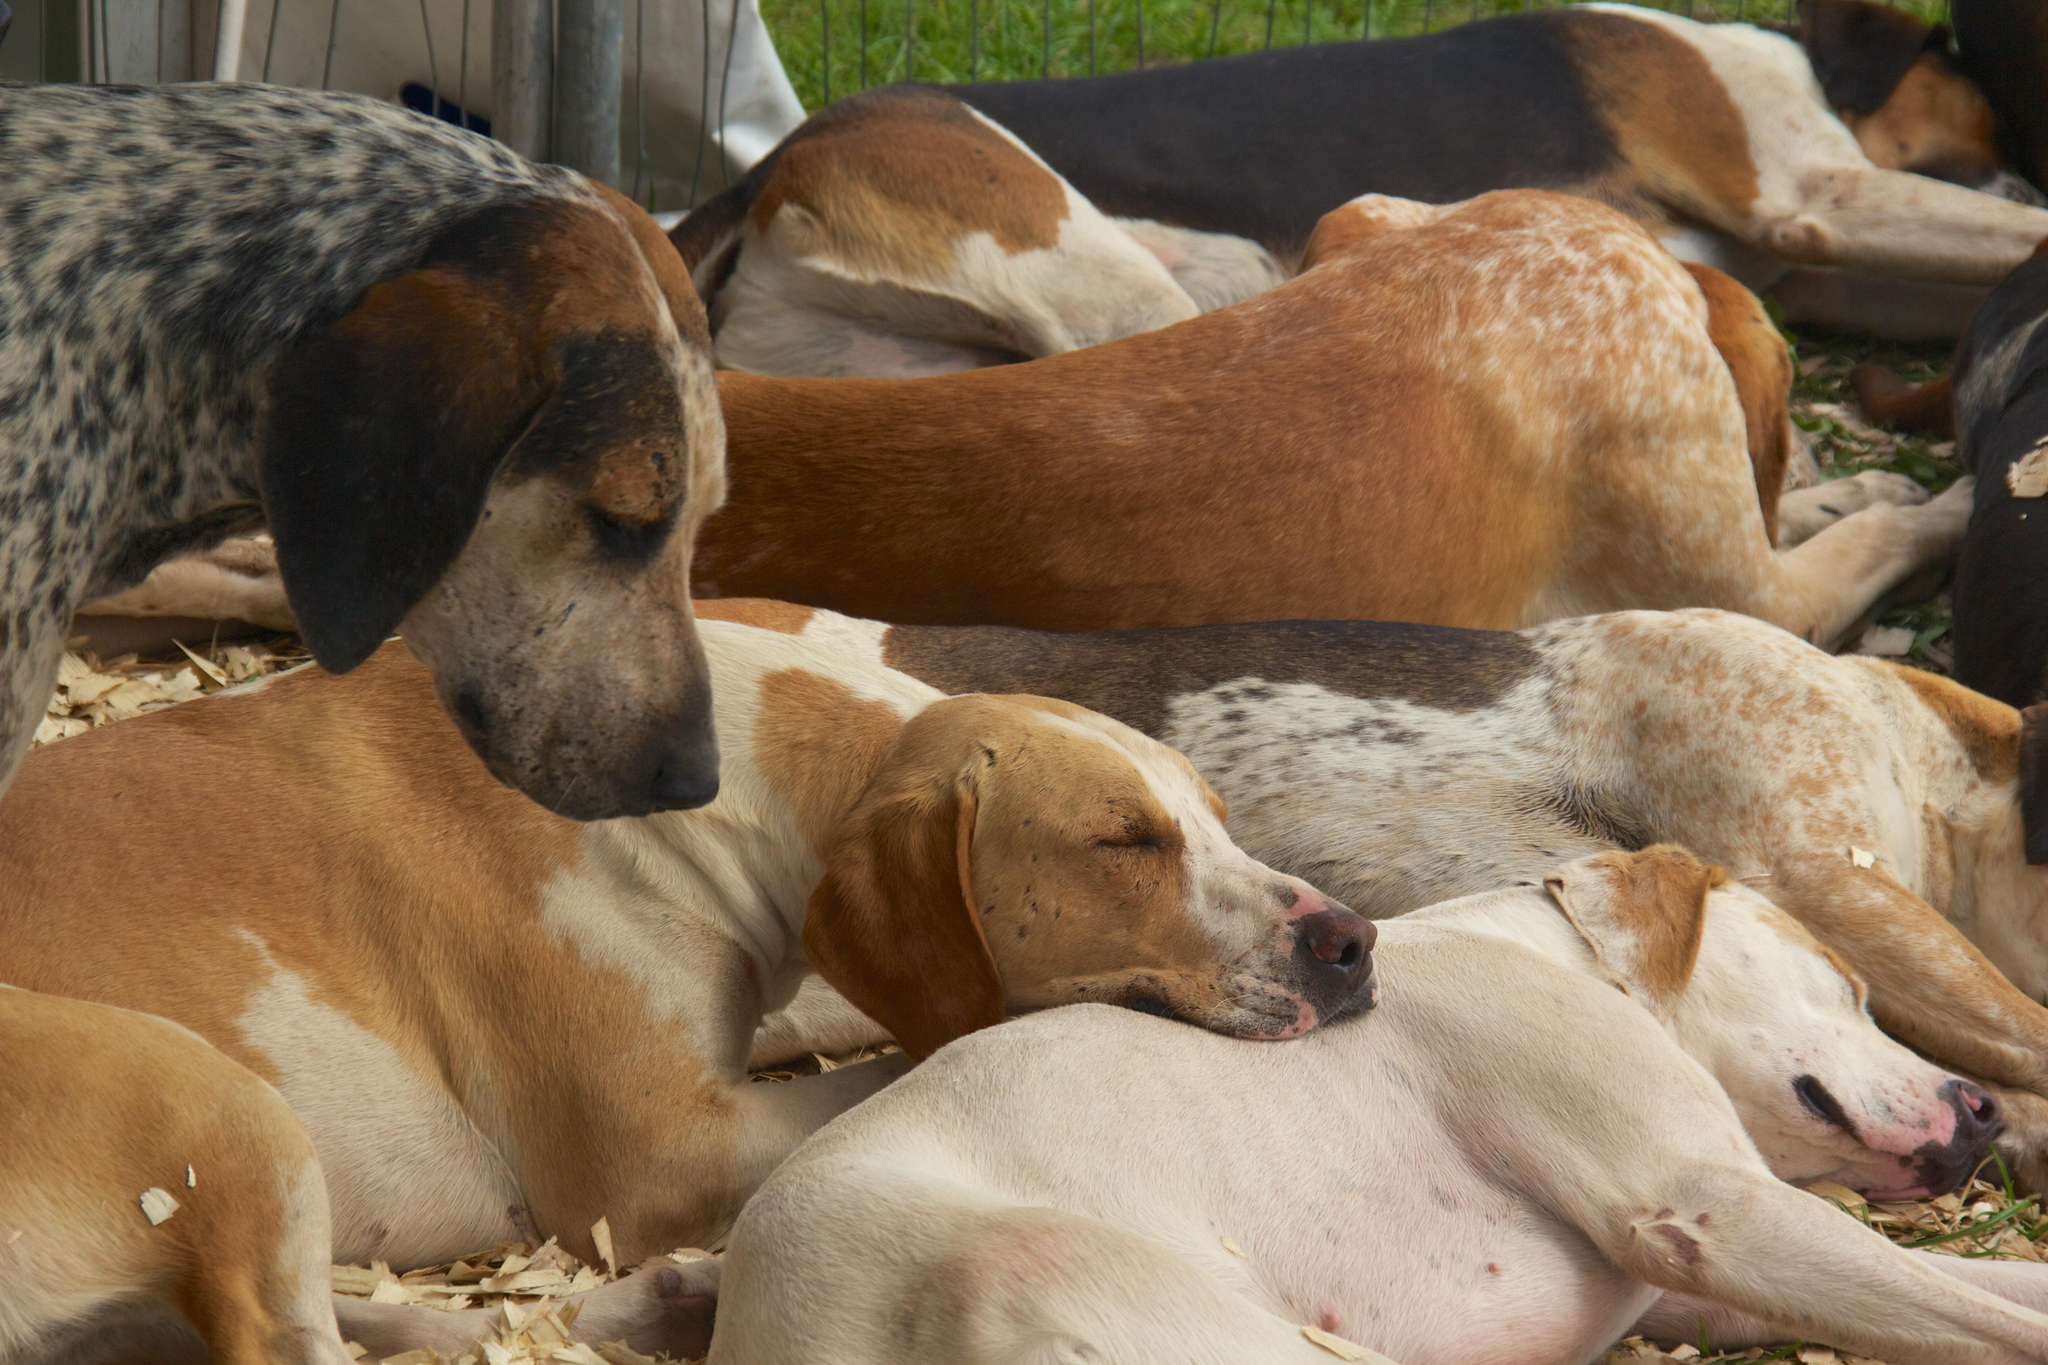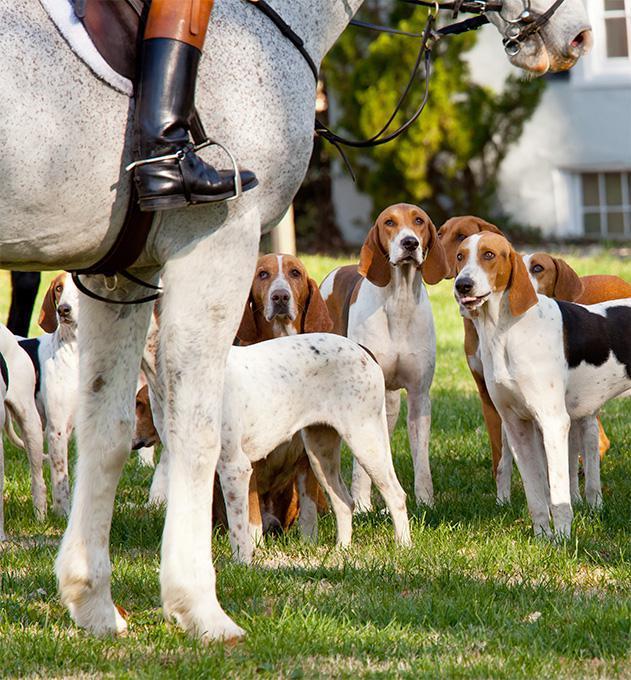The first image is the image on the left, the second image is the image on the right. For the images shown, is this caption "In one image, all dogs are running in a field." true? Answer yes or no. No. The first image is the image on the left, the second image is the image on the right. Assess this claim about the two images: "A persons leg is visible in the right image.". Correct or not? Answer yes or no. Yes. 